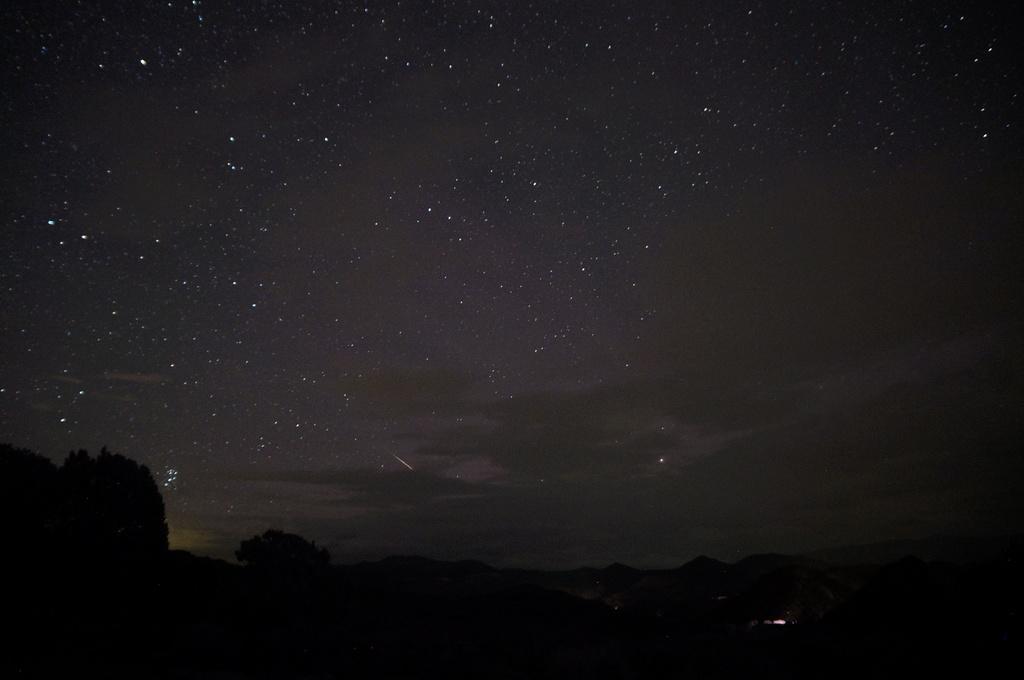Could you give a brief overview of what you see in this image? In this picture I can see trees, there are hills, and in the background there are stars in the sky. 